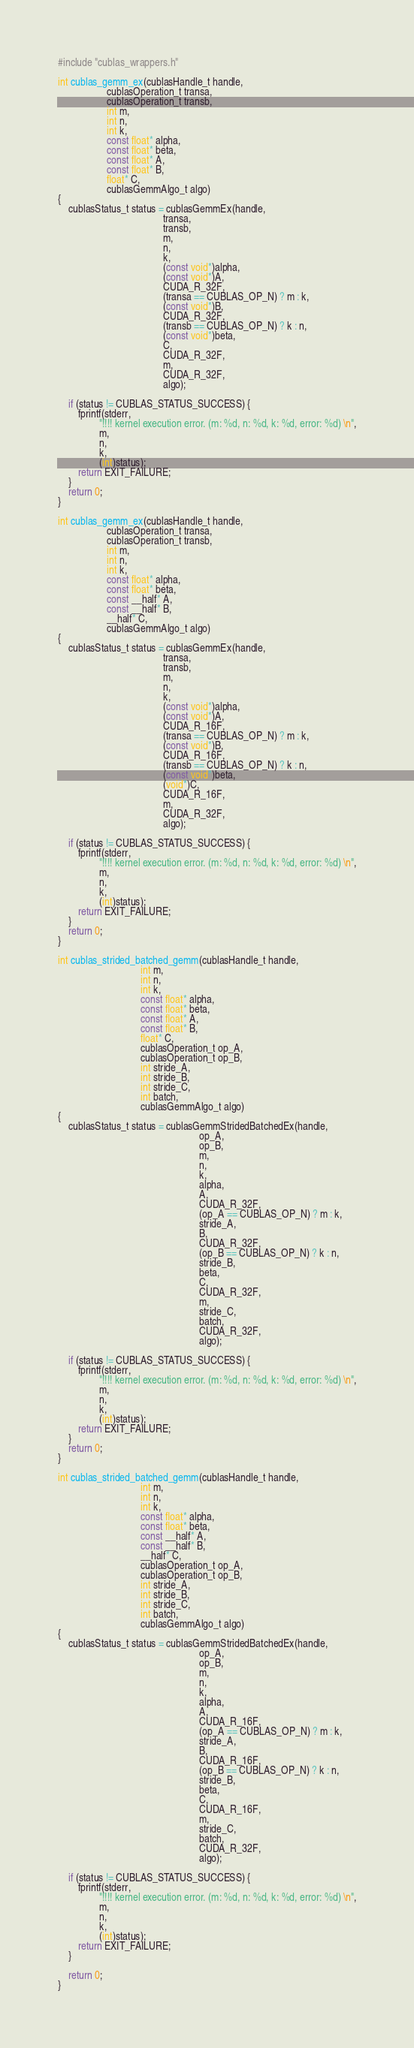<code> <loc_0><loc_0><loc_500><loc_500><_Cuda_>#include "cublas_wrappers.h"

int cublas_gemm_ex(cublasHandle_t handle,
                   cublasOperation_t transa,
                   cublasOperation_t transb,
                   int m,
                   int n,
                   int k,
                   const float* alpha,
                   const float* beta,
                   const float* A,
                   const float* B,
                   float* C,
                   cublasGemmAlgo_t algo)
{
    cublasStatus_t status = cublasGemmEx(handle,
                                         transa,
                                         transb,
                                         m,
                                         n,
                                         k,
                                         (const void*)alpha,
                                         (const void*)A,
                                         CUDA_R_32F,
                                         (transa == CUBLAS_OP_N) ? m : k,
                                         (const void*)B,
                                         CUDA_R_32F,
                                         (transb == CUBLAS_OP_N) ? k : n,
                                         (const void*)beta,
                                         C,
                                         CUDA_R_32F,
                                         m,
                                         CUDA_R_32F,
                                         algo);

    if (status != CUBLAS_STATUS_SUCCESS) {
        fprintf(stderr,
                "!!!! kernel execution error. (m: %d, n: %d, k: %d, error: %d) \n",
                m,
                n,
                k,
                (int)status);
        return EXIT_FAILURE;
    }
    return 0;
}

int cublas_gemm_ex(cublasHandle_t handle,
                   cublasOperation_t transa,
                   cublasOperation_t transb,
                   int m,
                   int n,
                   int k,
                   const float* alpha,
                   const float* beta,
                   const __half* A,
                   const __half* B,
                   __half* C,
                   cublasGemmAlgo_t algo)
{
    cublasStatus_t status = cublasGemmEx(handle,
                                         transa,
                                         transb,
                                         m,
                                         n,
                                         k,
                                         (const void*)alpha,
                                         (const void*)A,
                                         CUDA_R_16F,
                                         (transa == CUBLAS_OP_N) ? m : k,
                                         (const void*)B,
                                         CUDA_R_16F,
                                         (transb == CUBLAS_OP_N) ? k : n,
                                         (const void*)beta,
                                         (void*)C,
                                         CUDA_R_16F,
                                         m,
                                         CUDA_R_32F,
                                         algo);

    if (status != CUBLAS_STATUS_SUCCESS) {
        fprintf(stderr,
                "!!!! kernel execution error. (m: %d, n: %d, k: %d, error: %d) \n",
                m,
                n,
                k,
                (int)status);
        return EXIT_FAILURE;
    }
    return 0;
}

int cublas_strided_batched_gemm(cublasHandle_t handle,
                                int m,
                                int n,
                                int k,
                                const float* alpha,
                                const float* beta,
                                const float* A,
                                const float* B,
                                float* C,
                                cublasOperation_t op_A,
                                cublasOperation_t op_B,
                                int stride_A,
                                int stride_B,
                                int stride_C,
                                int batch,
                                cublasGemmAlgo_t algo)
{
    cublasStatus_t status = cublasGemmStridedBatchedEx(handle,
                                                       op_A,
                                                       op_B,
                                                       m,
                                                       n,
                                                       k,
                                                       alpha,
                                                       A,
                                                       CUDA_R_32F,
                                                       (op_A == CUBLAS_OP_N) ? m : k,
                                                       stride_A,
                                                       B,
                                                       CUDA_R_32F,
                                                       (op_B == CUBLAS_OP_N) ? k : n,
                                                       stride_B,
                                                       beta,
                                                       C,
                                                       CUDA_R_32F,
                                                       m,
                                                       stride_C,
                                                       batch,
                                                       CUDA_R_32F,
                                                       algo);

    if (status != CUBLAS_STATUS_SUCCESS) {
        fprintf(stderr,
                "!!!! kernel execution error. (m: %d, n: %d, k: %d, error: %d) \n",
                m,
                n,
                k,
                (int)status);
        return EXIT_FAILURE;
    }
    return 0;
}

int cublas_strided_batched_gemm(cublasHandle_t handle,
                                int m,
                                int n,
                                int k,
                                const float* alpha,
                                const float* beta,
                                const __half* A,
                                const __half* B,
                                __half* C,
                                cublasOperation_t op_A,
                                cublasOperation_t op_B,
                                int stride_A,
                                int stride_B,
                                int stride_C,
                                int batch,
                                cublasGemmAlgo_t algo)
{
    cublasStatus_t status = cublasGemmStridedBatchedEx(handle,
                                                       op_A,
                                                       op_B,
                                                       m,
                                                       n,
                                                       k,
                                                       alpha,
                                                       A,
                                                       CUDA_R_16F,
                                                       (op_A == CUBLAS_OP_N) ? m : k,
                                                       stride_A,
                                                       B,
                                                       CUDA_R_16F,
                                                       (op_B == CUBLAS_OP_N) ? k : n,
                                                       stride_B,
                                                       beta,
                                                       C,
                                                       CUDA_R_16F,
                                                       m,
                                                       stride_C,
                                                       batch,
                                                       CUDA_R_32F,
                                                       algo);

    if (status != CUBLAS_STATUS_SUCCESS) {
        fprintf(stderr,
                "!!!! kernel execution error. (m: %d, n: %d, k: %d, error: %d) \n",
                m,
                n,
                k,
                (int)status);
        return EXIT_FAILURE;
    }

    return 0;
}
</code> 